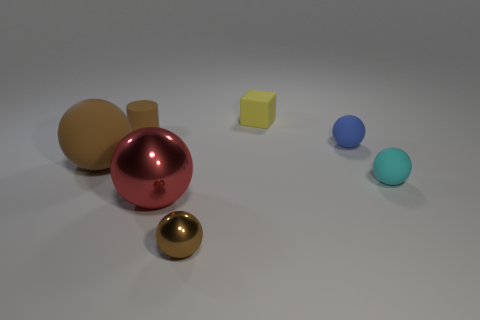Are there an equal number of tiny cyan objects to the left of the cyan rubber ball and cyan matte things left of the small blue thing?
Give a very brief answer. Yes. The tiny sphere that is both left of the cyan object and behind the red metal ball is what color?
Your answer should be very brief. Blue. Is there any other thing that is the same size as the red sphere?
Your response must be concise. Yes. Are there more red things on the right side of the cyan matte thing than cylinders behind the small yellow rubber thing?
Offer a very short reply. No. Is the size of the object that is right of the blue matte sphere the same as the small blue sphere?
Make the answer very short. Yes. There is a metallic object that is behind the brown ball right of the small rubber cylinder; what number of big things are behind it?
Your response must be concise. 1. There is a sphere that is both in front of the blue matte thing and on the right side of the tiny yellow matte object; how big is it?
Offer a very short reply. Small. What number of other objects are the same shape as the small brown rubber thing?
Provide a short and direct response. 0. There is a small rubber cylinder; what number of brown cylinders are behind it?
Keep it short and to the point. 0. Is the number of tiny blocks to the right of the cyan object less than the number of large red metallic balls that are behind the small cylinder?
Ensure brevity in your answer.  No. 